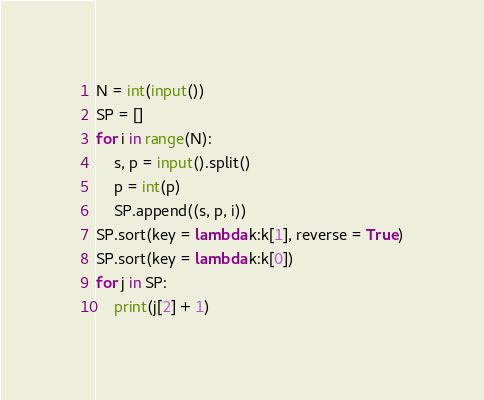Convert code to text. <code><loc_0><loc_0><loc_500><loc_500><_Python_>N = int(input())
SP = []
for i in range(N):
    s, p = input().split()
    p = int(p)
    SP.append((s, p, i))
SP.sort(key = lambda k:k[1], reverse = True)
SP.sort(key = lambda k:k[0])
for j in SP:
    print(j[2] + 1)
</code> 